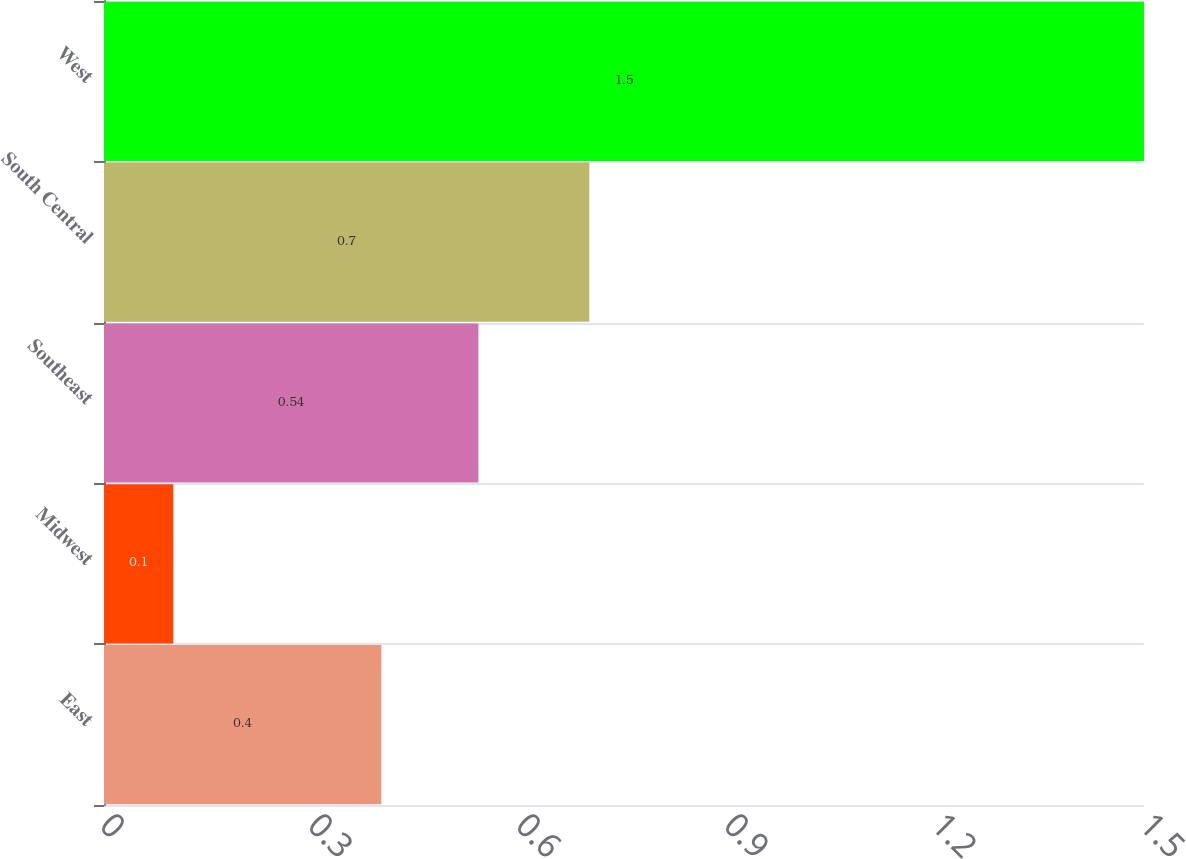Convert chart to OTSL. <chart><loc_0><loc_0><loc_500><loc_500><bar_chart><fcel>East<fcel>Midwest<fcel>Southeast<fcel>South Central<fcel>West<nl><fcel>0.4<fcel>0.1<fcel>0.54<fcel>0.7<fcel>1.5<nl></chart> 